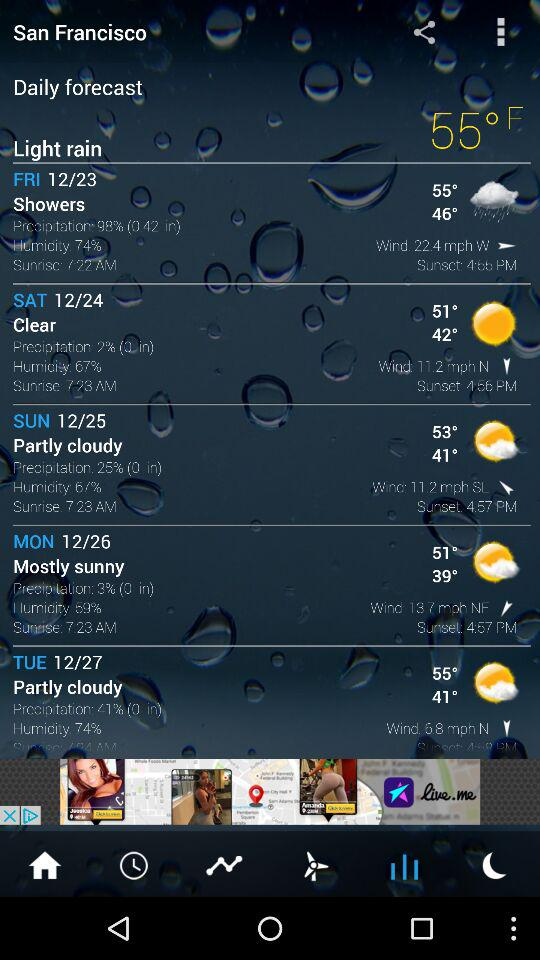What is the weather like on Wednesday?
When the provided information is insufficient, respond with <no answer>. <no answer> 